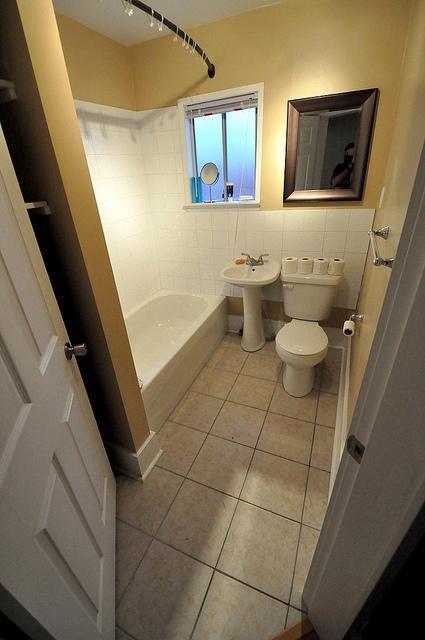How many rolls of toilet paper are on top of the toilet?
Give a very brief answer. 4. 